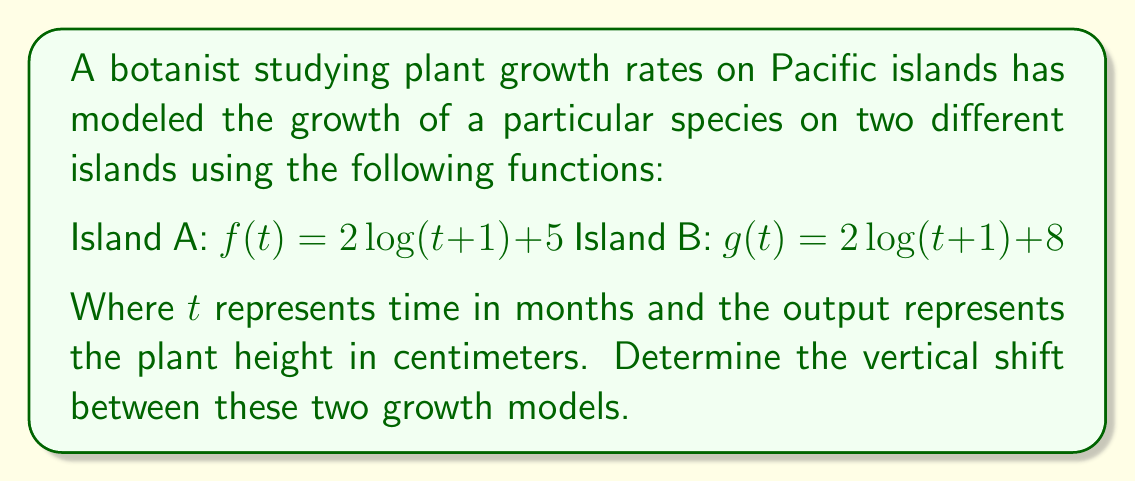Teach me how to tackle this problem. To determine the vertical shift between two functions, we need to compare their vertical positions relative to each other. In this case, both functions have the same base function $2\log(t+1)$, but they differ in their constant terms.

1) For Island A, the function is $f(t) = 2\log(t+1) + 5$
2) For Island B, the function is $g(t) = 2\log(t+1) + 8$

The vertical shift is the difference between these constant terms:

$8 - 5 = 3$

This means that the function $g(t)$ is shifted 3 units upward compared to $f(t)$. In the context of plant growth, this indicates that plants on Island B are consistently 3 cm taller than those on Island A at any given time $t$.

We can verify this by comparing the two functions for any value of $t$:

$g(t) - f(t) = [2\log(t+1) + 8] - [2\log(t+1) + 5]$
$= 2\log(t+1) + 8 - 2\log(t+1) - 5$
$= 8 - 5 = 3$

This confirms that the vertical shift is indeed 3 units upward for $g(t)$ relative to $f(t)$.
Answer: The vertical shift between the two growth models is 3 units upward for the function modeling plant growth on Island B relative to Island A. 